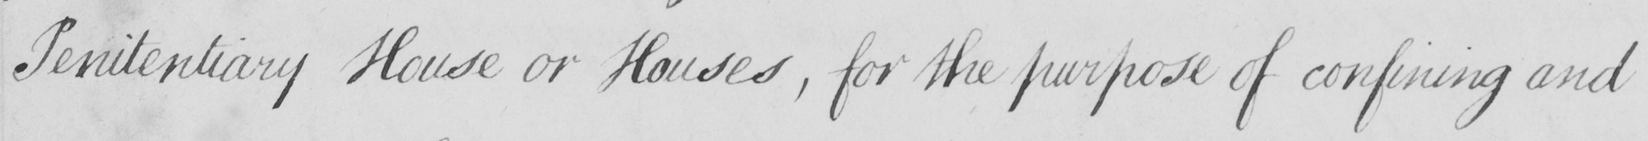What text is written in this handwritten line? Penitentiary House or Houses , for the purpose of confining and 